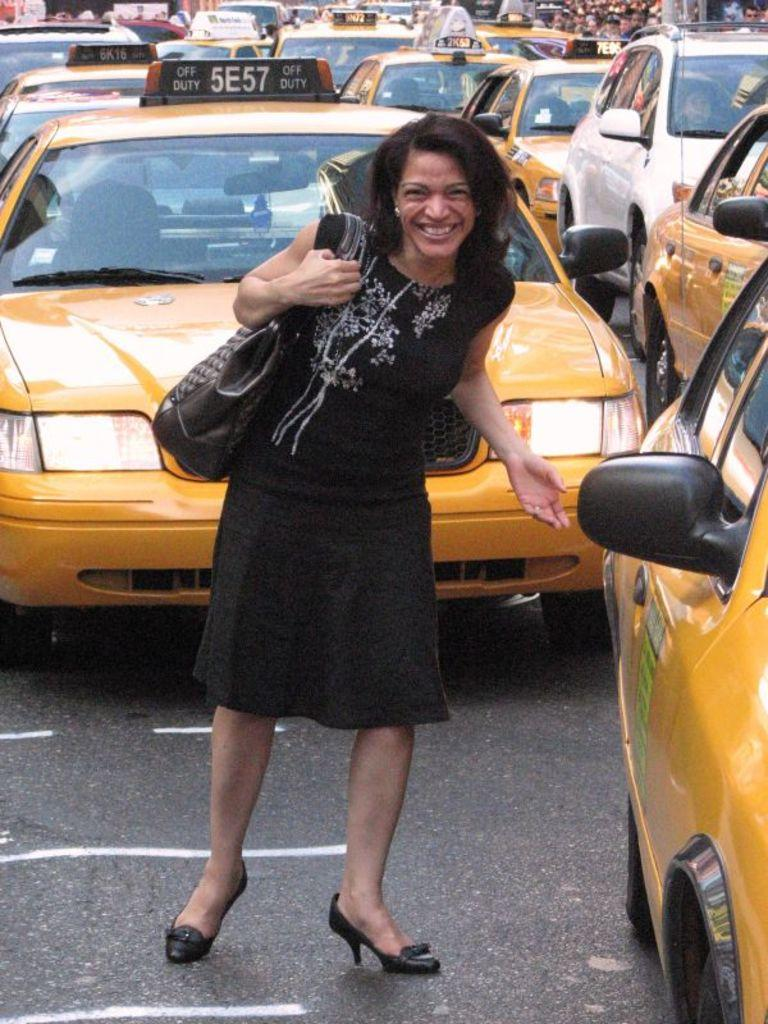<image>
Give a short and clear explanation of the subsequent image. A woman in black is in front of a cab with number 5E57. 